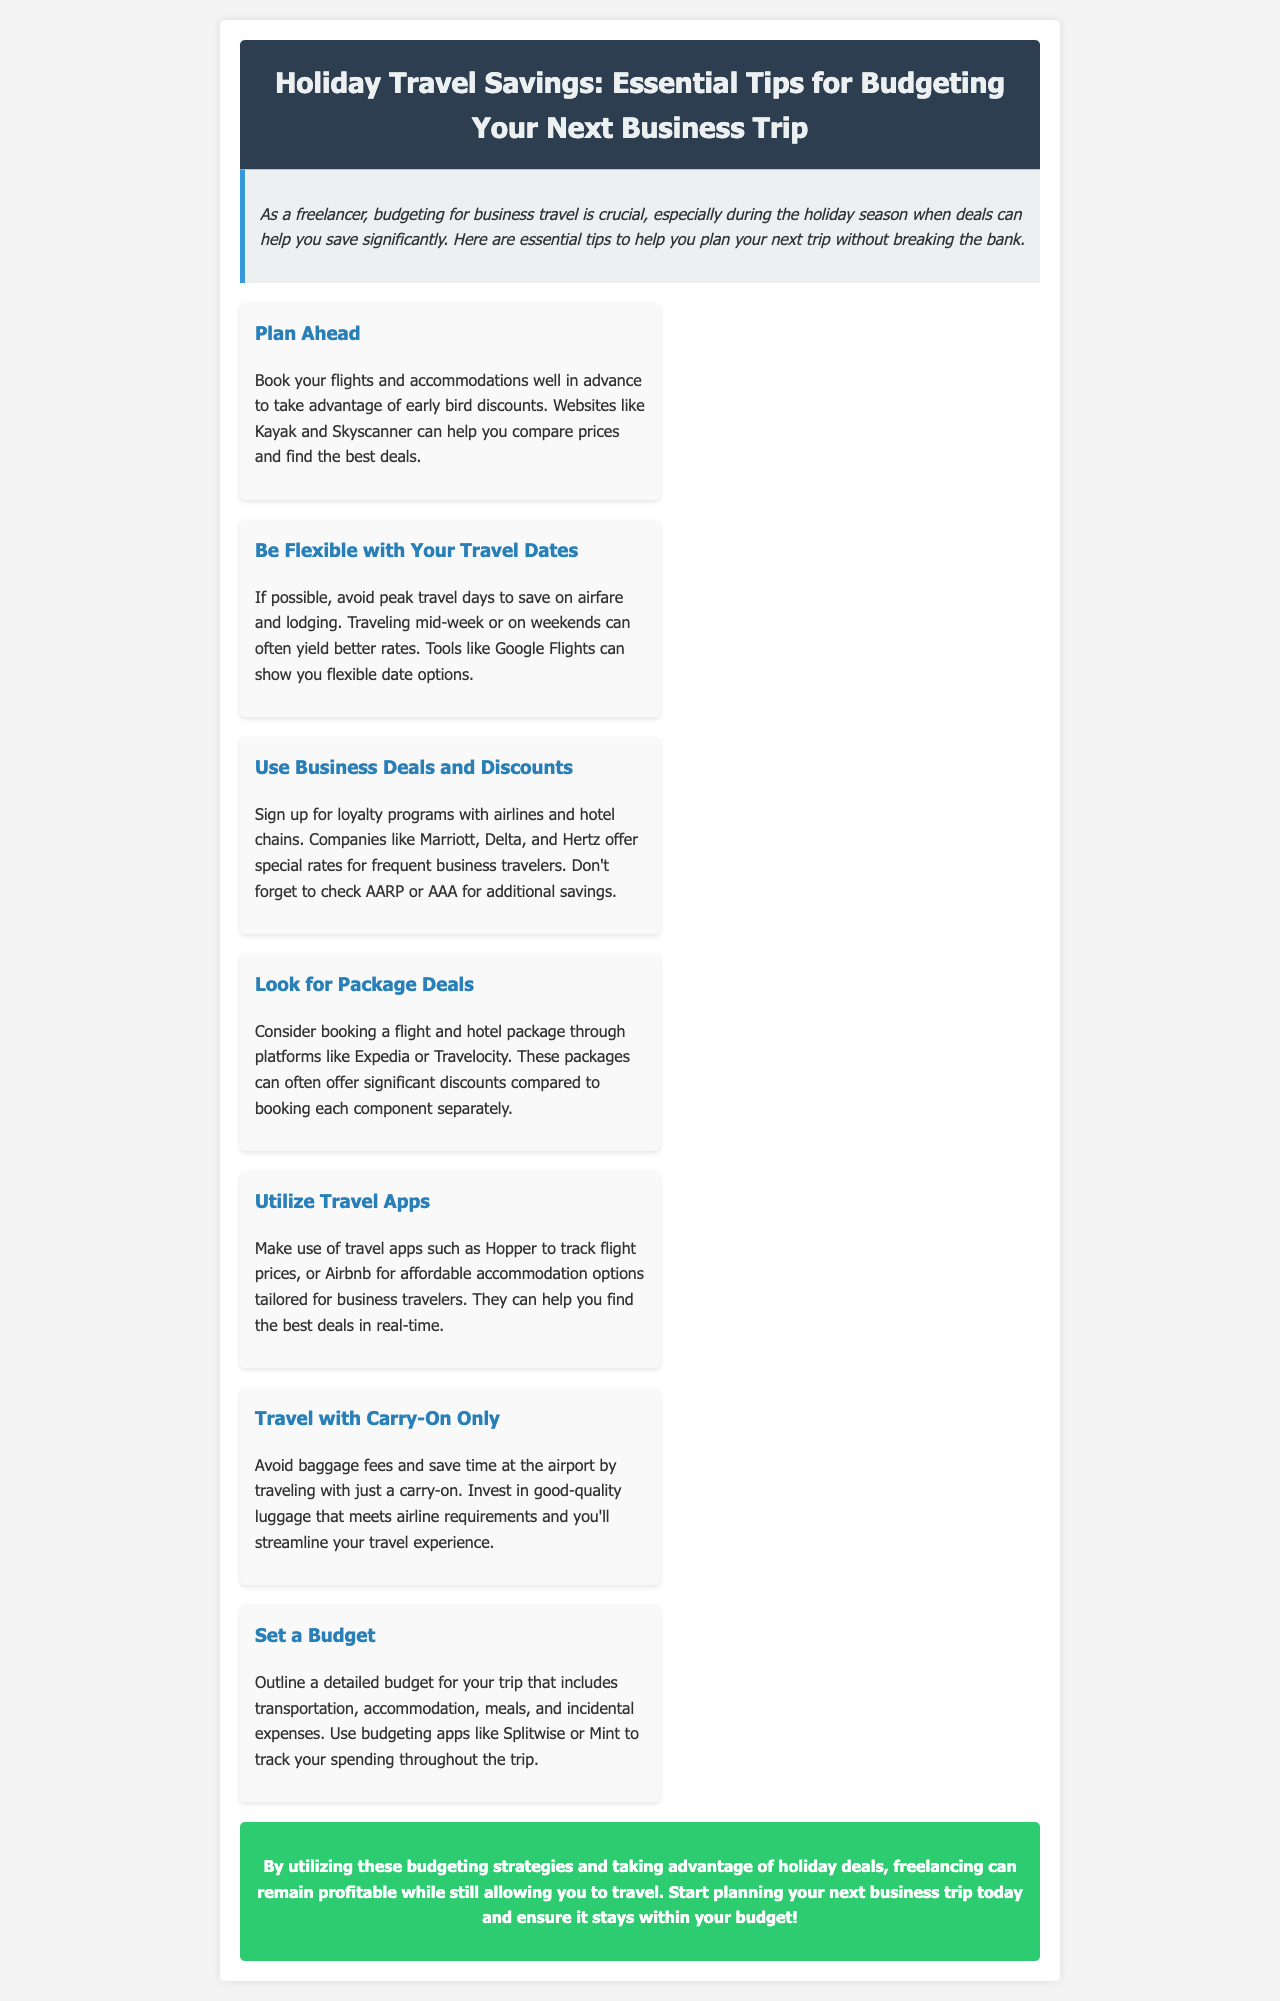What is the title of the newsletter? The title of the newsletter is found in the header section, which is "Holiday Travel Savings: Essential Tips for Budgeting Your Next Business Trip."
Answer: Holiday Travel Savings: Essential Tips for Budgeting Your Next Business Trip Who should utilize these budgeting strategies? The introduction states that freelancers should utilize these budgeting strategies, specifically targeting their needs for business travel.
Answer: Freelancers What is one recommended website for comparing flight prices? The document suggests using Kayak and Skyscanner for comparing flight prices in the tip about planning ahead.
Answer: Kayak What can you track with the app Hopper? The tip about utilizing travel apps mentions that you can track flight prices using the app Hopper.
Answer: Flight prices Which type of deals should you sign up for with airlines and hotel chains? The tip about business deals and discounts advises signing up for loyalty programs with airlines and hotel chains to benefit from special rates.
Answer: Loyalty programs What should you include in your trip budget? The tip about setting a budget recommends outlining a budget that includes transportation, accommodation, meals, and incidental expenses.
Answer: Transportation, accommodation, meals, and incidental expenses What is a preferred accommodation option mentioned in the document? The tip about utilizing travel apps suggests Airbnb as an affordable accommodation option for business travelers.
Answer: Airbnb What does traveling with carry-on only help you avoid? The tip about traveling with carry-on only highlights that it helps avoid baggage fees at the airport.
Answer: Baggage fees 